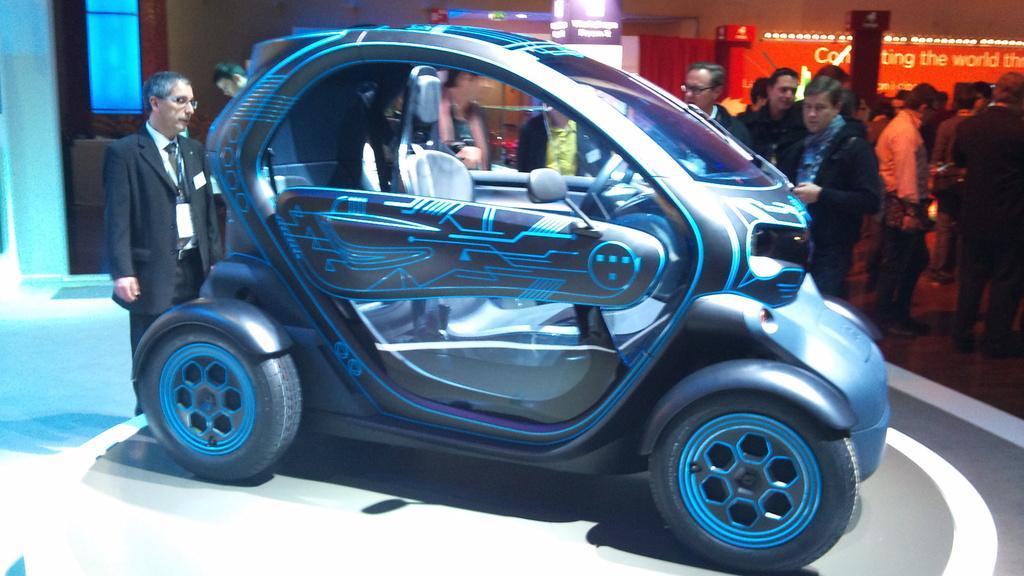In one or two sentences, can you explain what this image depicts? This image is taken indoors. At the bottom of the image there is a floor. In the middle of the image there is a vintage car parked on the floor and there is a man standing on the floor. In the background there is a wall with a window and a board with text on it and there are many people standing on the floor. 